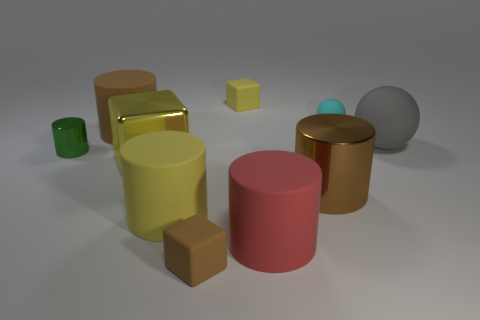Subtract all small yellow blocks. How many blocks are left? 2 Subtract all cubes. How many objects are left? 7 Subtract all yellow cylinders. How many cylinders are left? 4 Subtract 1 spheres. How many spheres are left? 1 Subtract all purple cubes. Subtract all yellow spheres. How many cubes are left? 3 Subtract all brown blocks. How many red spheres are left? 0 Subtract all cyan balls. Subtract all gray spheres. How many objects are left? 8 Add 1 rubber cylinders. How many rubber cylinders are left? 4 Add 5 large purple shiny cylinders. How many large purple shiny cylinders exist? 5 Subtract 0 brown spheres. How many objects are left? 10 